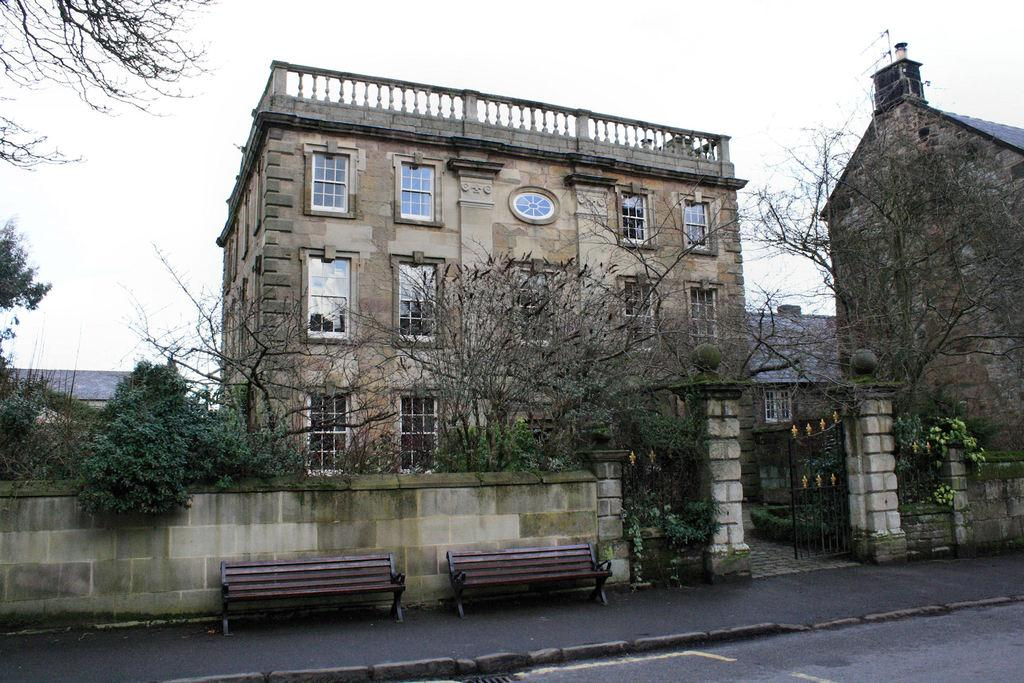What type of seating is located at the bottom of the image? There are benches at the bottom of the image. What can be seen in the middle of the image? There are trees in the middle of the image. What type of structures are visible in the background of the image? There are buildings in the background of the image. What is visible at the top of the image? The sky is visible at the top of the image. Where is the drain located in the image? There is no drain present in the image. What type of rail can be seen in the image? There is no rail present in the image. 